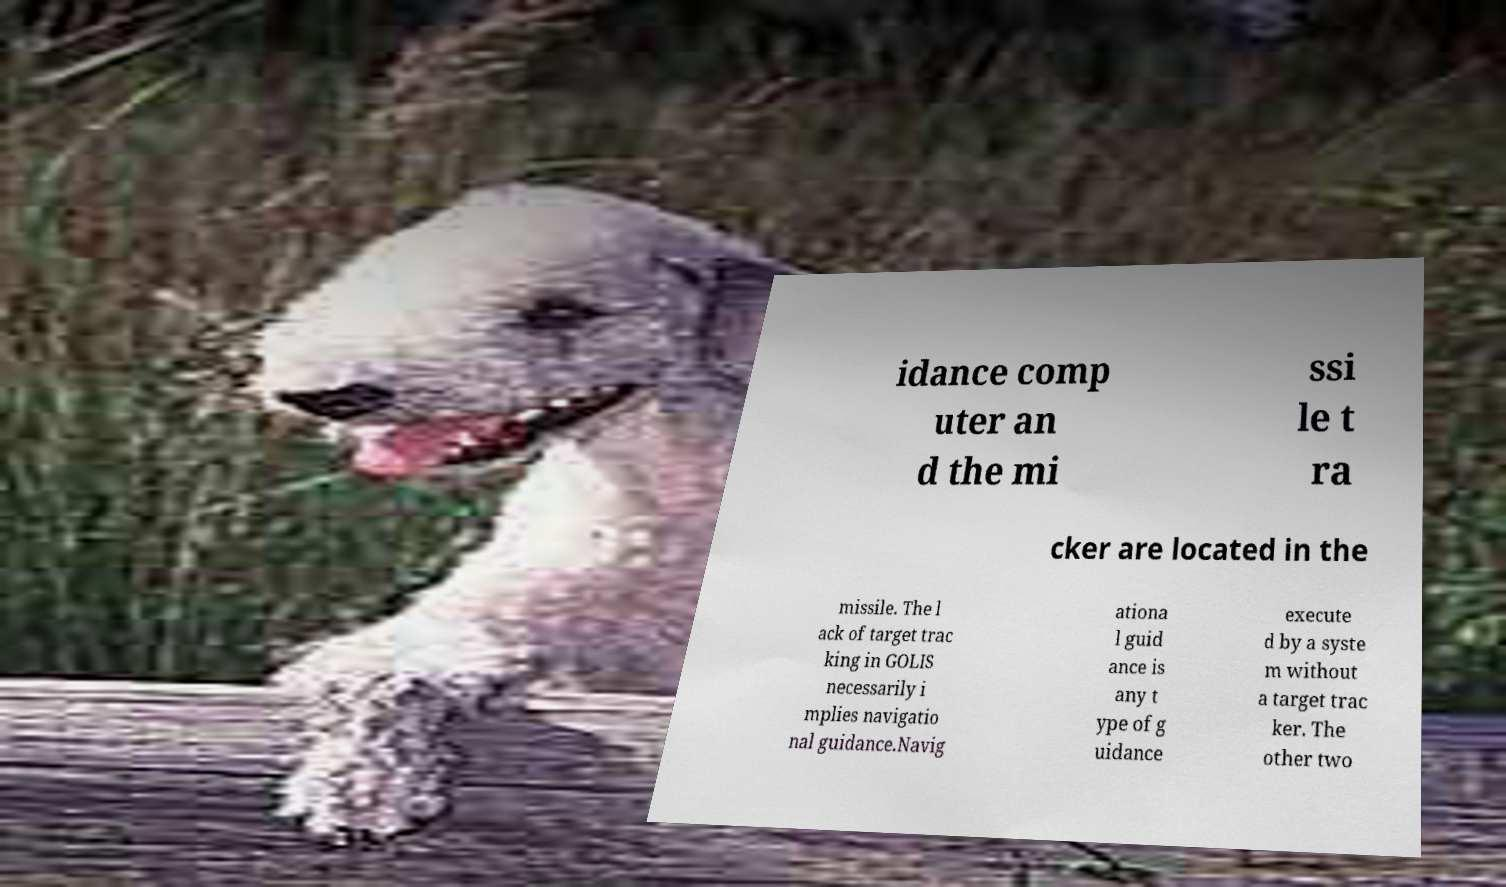I need the written content from this picture converted into text. Can you do that? idance comp uter an d the mi ssi le t ra cker are located in the missile. The l ack of target trac king in GOLIS necessarily i mplies navigatio nal guidance.Navig ationa l guid ance is any t ype of g uidance execute d by a syste m without a target trac ker. The other two 